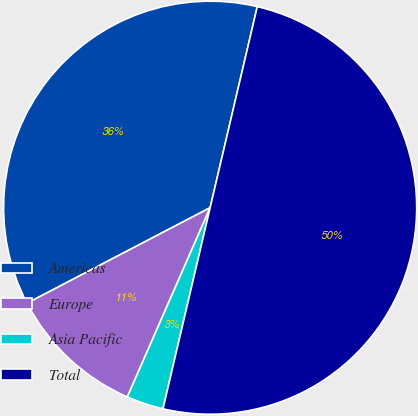<chart> <loc_0><loc_0><loc_500><loc_500><pie_chart><fcel>Americas<fcel>Europe<fcel>Asia Pacific<fcel>Total<nl><fcel>36.32%<fcel>10.78%<fcel>2.9%<fcel>50.0%<nl></chart> 